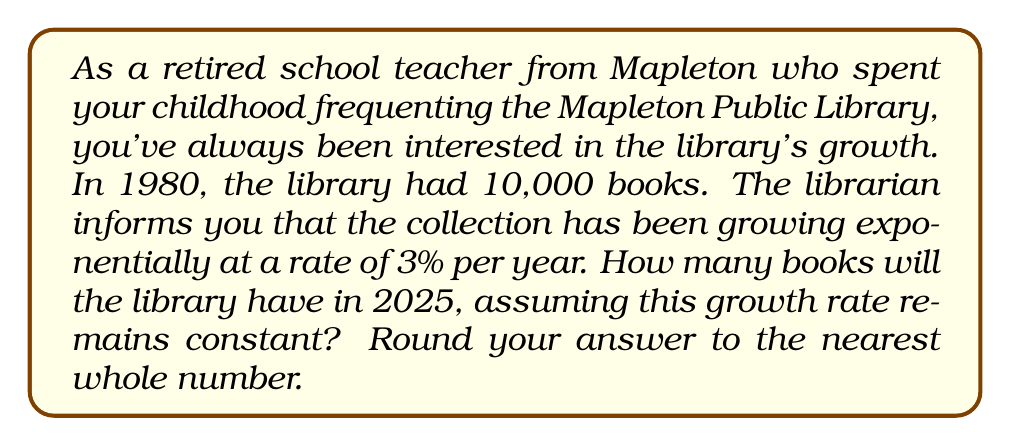Provide a solution to this math problem. Let's approach this step-by-step using an exponential function:

1) The exponential growth function is given by:
   $$A(t) = A_0(1 + r)^t$$
   where:
   $A(t)$ is the amount after time $t$
   $A_0$ is the initial amount
   $r$ is the growth rate (as a decimal)
   $t$ is the time in years

2) We know:
   $A_0 = 10,000$ (initial number of books in 1980)
   $r = 0.03$ (3% growth rate)
   $t = 2025 - 1980 = 45$ years

3) Plugging these values into our function:
   $$A(45) = 10,000(1 + 0.03)^{45}$$

4) Let's calculate this:
   $$A(45) = 10,000(1.03)^{45}$$
   $$A(45) = 10,000(3.7816)$$
   $$A(45) = 37,816$$

5) Rounding to the nearest whole number:
   $A(45) \approx 37,816$ books
Answer: 37,816 books 